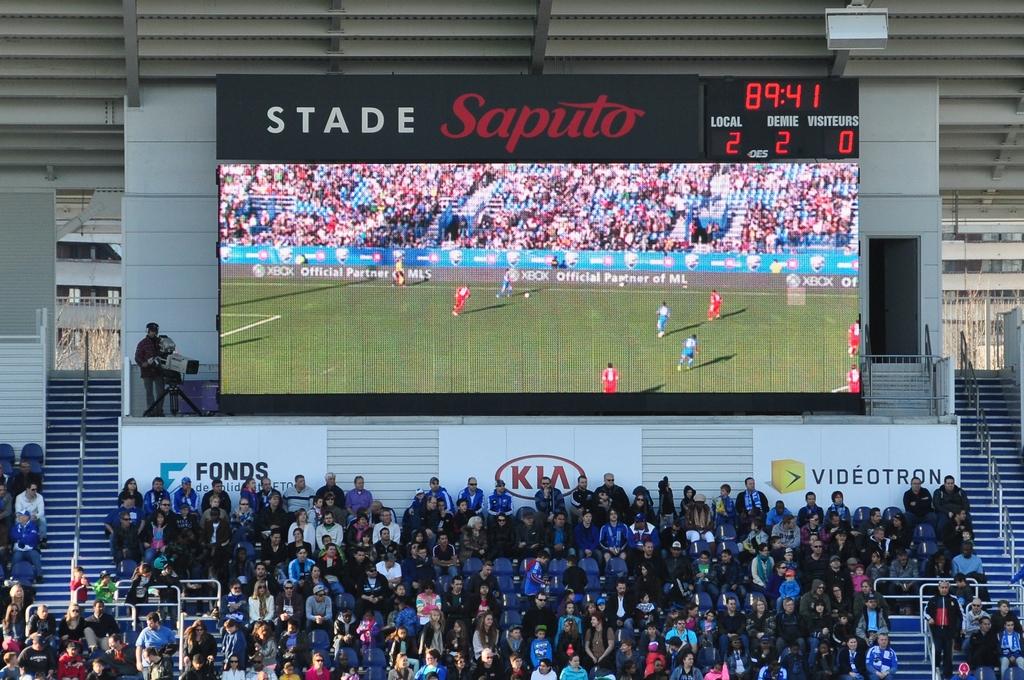What advertiser is at the bottom middle of the screen?
Make the answer very short. Kia. What sport are they watching?
Your response must be concise. Answering does not require reading text in the image. 